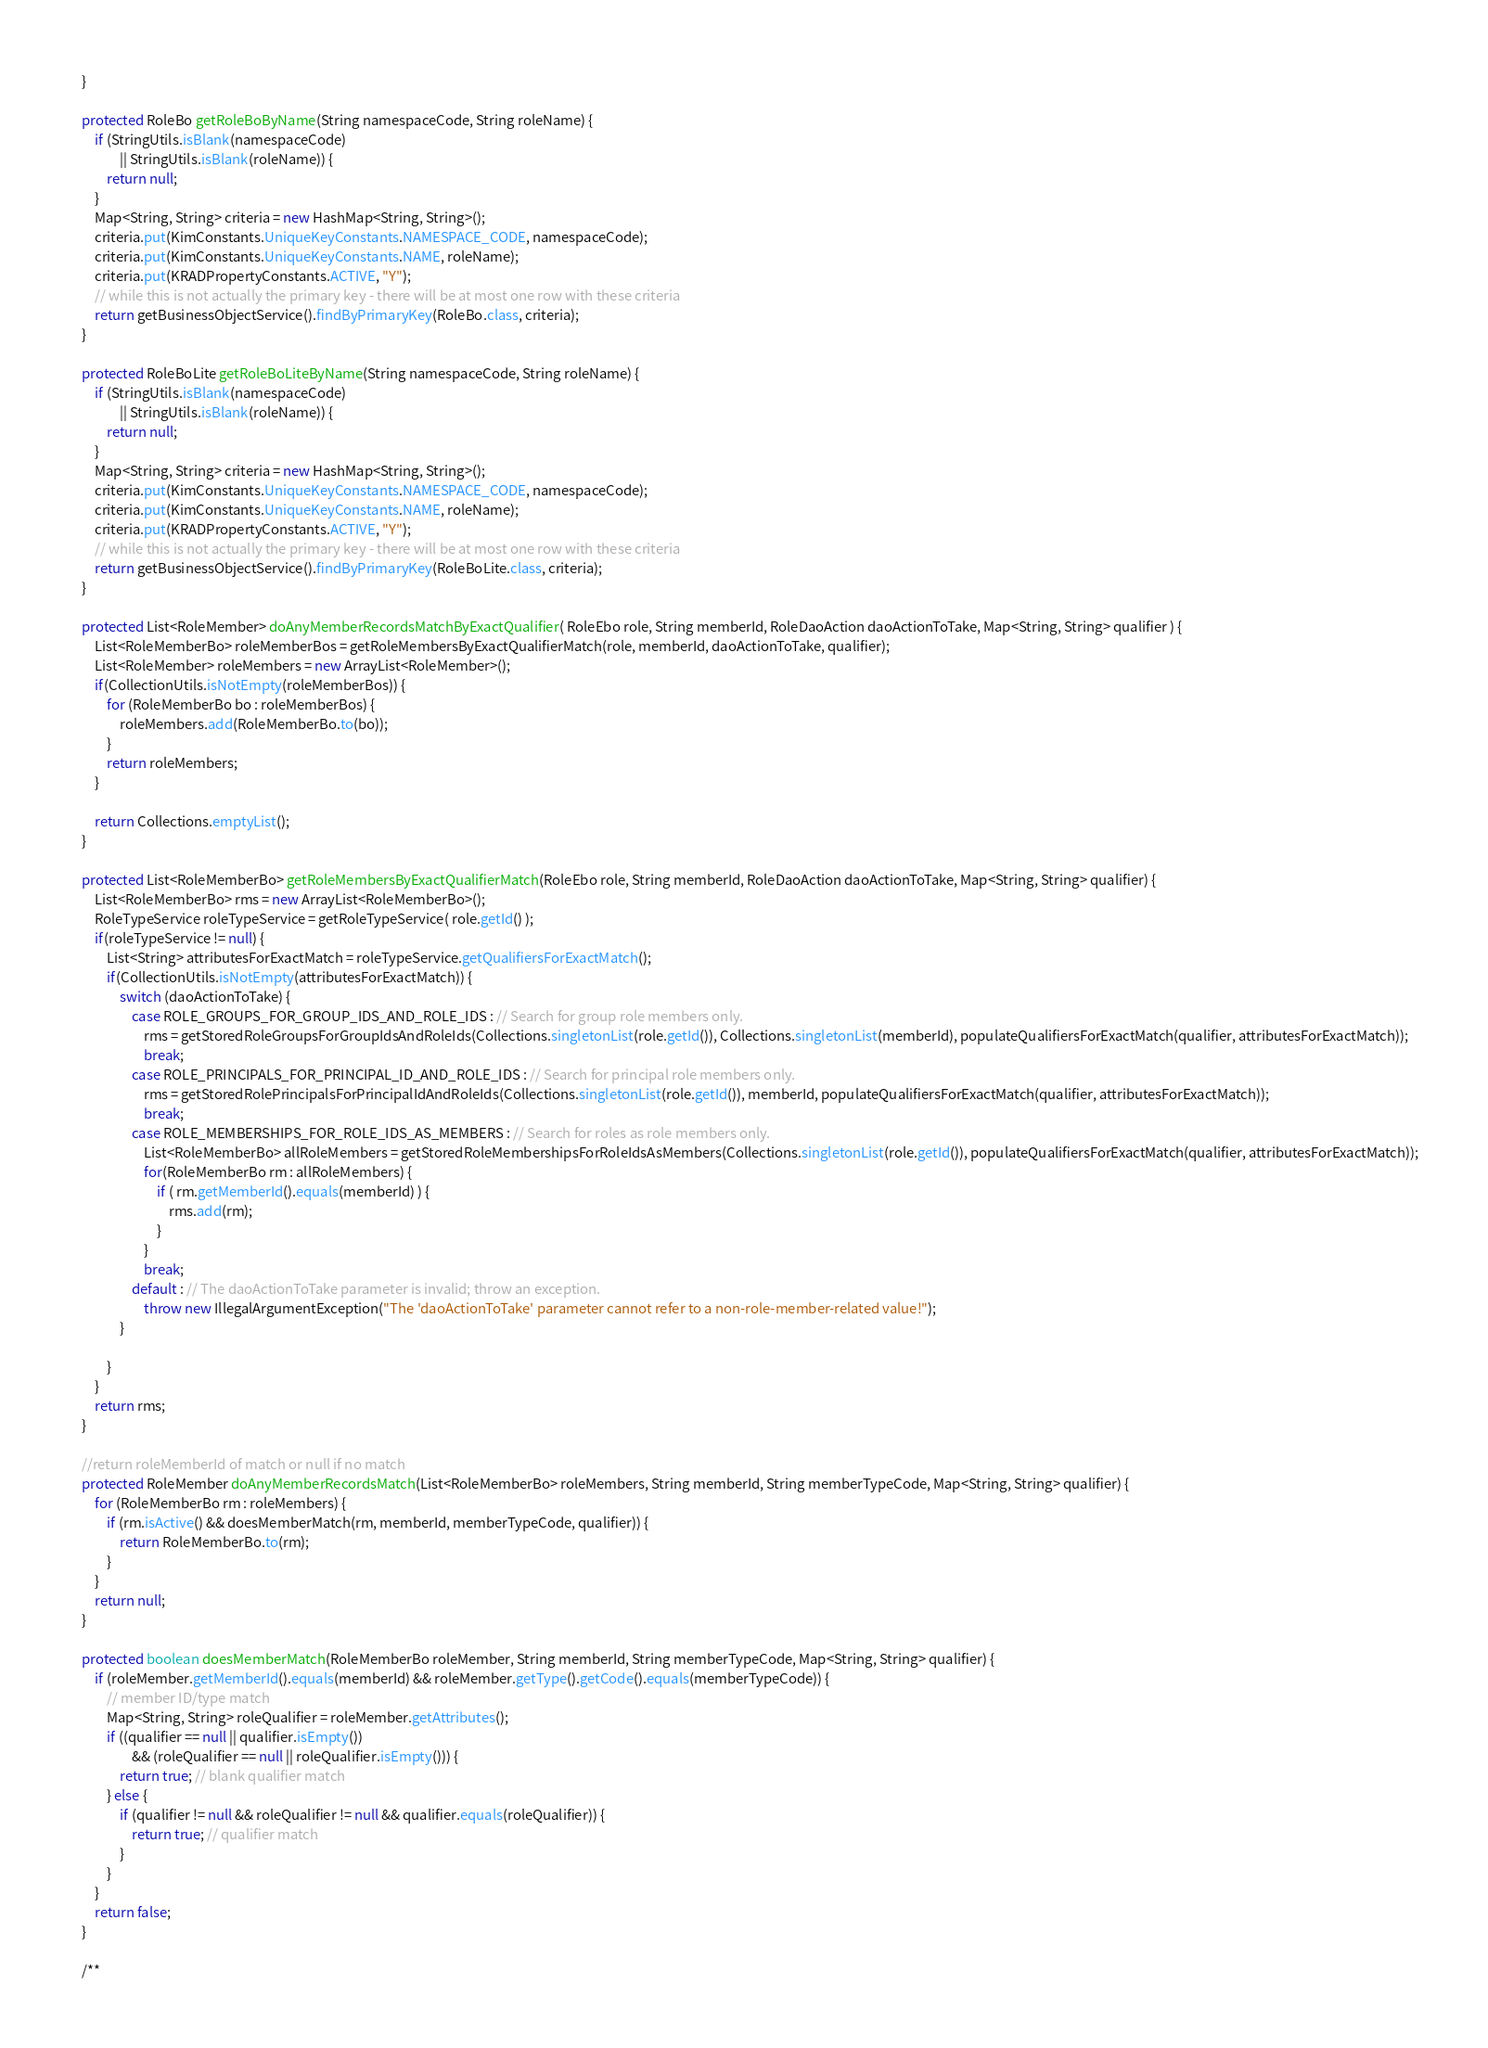<code> <loc_0><loc_0><loc_500><loc_500><_Java_>
    }

    protected RoleBo getRoleBoByName(String namespaceCode, String roleName) {
        if (StringUtils.isBlank(namespaceCode)
                || StringUtils.isBlank(roleName)) {
            return null;
        }
        Map<String, String> criteria = new HashMap<String, String>();
        criteria.put(KimConstants.UniqueKeyConstants.NAMESPACE_CODE, namespaceCode);
        criteria.put(KimConstants.UniqueKeyConstants.NAME, roleName);
        criteria.put(KRADPropertyConstants.ACTIVE, "Y");
        // while this is not actually the primary key - there will be at most one row with these criteria
        return getBusinessObjectService().findByPrimaryKey(RoleBo.class, criteria);
    }
    
    protected RoleBoLite getRoleBoLiteByName(String namespaceCode, String roleName) {
        if (StringUtils.isBlank(namespaceCode)
                || StringUtils.isBlank(roleName)) {
            return null;
        }
        Map<String, String> criteria = new HashMap<String, String>();
        criteria.put(KimConstants.UniqueKeyConstants.NAMESPACE_CODE, namespaceCode);
        criteria.put(KimConstants.UniqueKeyConstants.NAME, roleName);
        criteria.put(KRADPropertyConstants.ACTIVE, "Y");
        // while this is not actually the primary key - there will be at most one row with these criteria
        return getBusinessObjectService().findByPrimaryKey(RoleBoLite.class, criteria);
    }

	protected List<RoleMember> doAnyMemberRecordsMatchByExactQualifier( RoleEbo role, String memberId, RoleDaoAction daoActionToTake, Map<String, String> qualifier ) {
		List<RoleMemberBo> roleMemberBos = getRoleMembersByExactQualifierMatch(role, memberId, daoActionToTake, qualifier);
        List<RoleMember> roleMembers = new ArrayList<RoleMember>();
        if(CollectionUtils.isNotEmpty(roleMemberBos)) {
            for (RoleMemberBo bo : roleMemberBos) {
                roleMembers.add(RoleMemberBo.to(bo));
            }
			return roleMembers;
		}

		return Collections.emptyList();
	}
	
	protected List<RoleMemberBo> getRoleMembersByExactQualifierMatch(RoleEbo role, String memberId, RoleDaoAction daoActionToTake, Map<String, String> qualifier) {
		List<RoleMemberBo> rms = new ArrayList<RoleMemberBo>();
		RoleTypeService roleTypeService = getRoleTypeService( role.getId() );
		if(roleTypeService != null) {
    		List<String> attributesForExactMatch = roleTypeService.getQualifiersForExactMatch();
    		if(CollectionUtils.isNotEmpty(attributesForExactMatch)) {
    			switch (daoActionToTake) {
	    			case ROLE_GROUPS_FOR_GROUP_IDS_AND_ROLE_IDS : // Search for group role members only.
	        			rms = getStoredRoleGroupsForGroupIdsAndRoleIds(Collections.singletonList(role.getId()), Collections.singletonList(memberId), populateQualifiersForExactMatch(qualifier, attributesForExactMatch));
	    				break;
	    			case ROLE_PRINCIPALS_FOR_PRINCIPAL_ID_AND_ROLE_IDS : // Search for principal role members only.
	        			rms = getStoredRolePrincipalsForPrincipalIdAndRoleIds(Collections.singletonList(role.getId()), memberId, populateQualifiersForExactMatch(qualifier, attributesForExactMatch));
	    				break;
	    			case ROLE_MEMBERSHIPS_FOR_ROLE_IDS_AS_MEMBERS : // Search for roles as role members only.
	    				List<RoleMemberBo> allRoleMembers = getStoredRoleMembershipsForRoleIdsAsMembers(Collections.singletonList(role.getId()), populateQualifiersForExactMatch(qualifier, attributesForExactMatch));
	        			for(RoleMemberBo rm : allRoleMembers) {
	        				if ( rm.getMemberId().equals(memberId) ) { 
	        					rms.add(rm);
	        				}
	        			}
                        break;
	    			default : // The daoActionToTake parameter is invalid; throw an exception.
	    				throw new IllegalArgumentException("The 'daoActionToTake' parameter cannot refer to a non-role-member-related value!");
    			}
    			
    		} 
		}
		return rms;
	}
    
    //return roleMemberId of match or null if no match
    protected RoleMember doAnyMemberRecordsMatch(List<RoleMemberBo> roleMembers, String memberId, String memberTypeCode, Map<String, String> qualifier) {
        for (RoleMemberBo rm : roleMembers) {
            if (rm.isActive() && doesMemberMatch(rm, memberId, memberTypeCode, qualifier)) {
                return RoleMemberBo.to(rm);
            }
        }
        return null;
    }

    protected boolean doesMemberMatch(RoleMemberBo roleMember, String memberId, String memberTypeCode, Map<String, String> qualifier) {
        if (roleMember.getMemberId().equals(memberId) && roleMember.getType().getCode().equals(memberTypeCode)) {
            // member ID/type match
            Map<String, String> roleQualifier = roleMember.getAttributes();
            if ((qualifier == null || qualifier.isEmpty())
                    && (roleQualifier == null || roleQualifier.isEmpty())) {
                return true; // blank qualifier match
            } else {
                if (qualifier != null && roleQualifier != null && qualifier.equals(roleQualifier)) {
                    return true; // qualifier match
                }
            }
        }
        return false;
    }
    
    /**</code> 